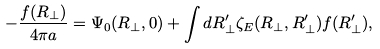<formula> <loc_0><loc_0><loc_500><loc_500>- \frac { f ( { R } _ { \perp } ) } { 4 \pi a } = \Psi _ { 0 } ( { R } _ { \perp } , 0 ) + \int d { R } _ { \perp } ^ { \prime } \zeta _ { E } ( { R } _ { \perp } , { R } _ { \perp } ^ { \prime } ) f ( { R } _ { \perp } ^ { \prime } ) ,</formula> 